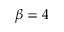<formula> <loc_0><loc_0><loc_500><loc_500>\beta = 4</formula> 